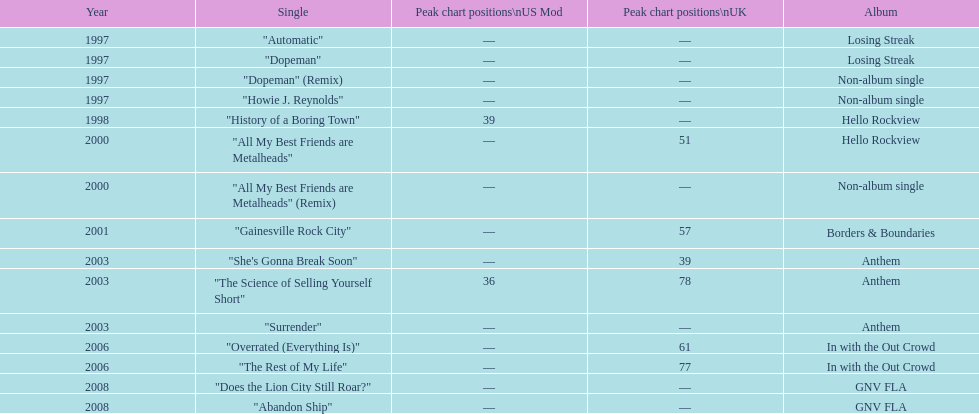Besides "dopeman", mention one more solitary tune present on the album "losing streak". "Automatic". 